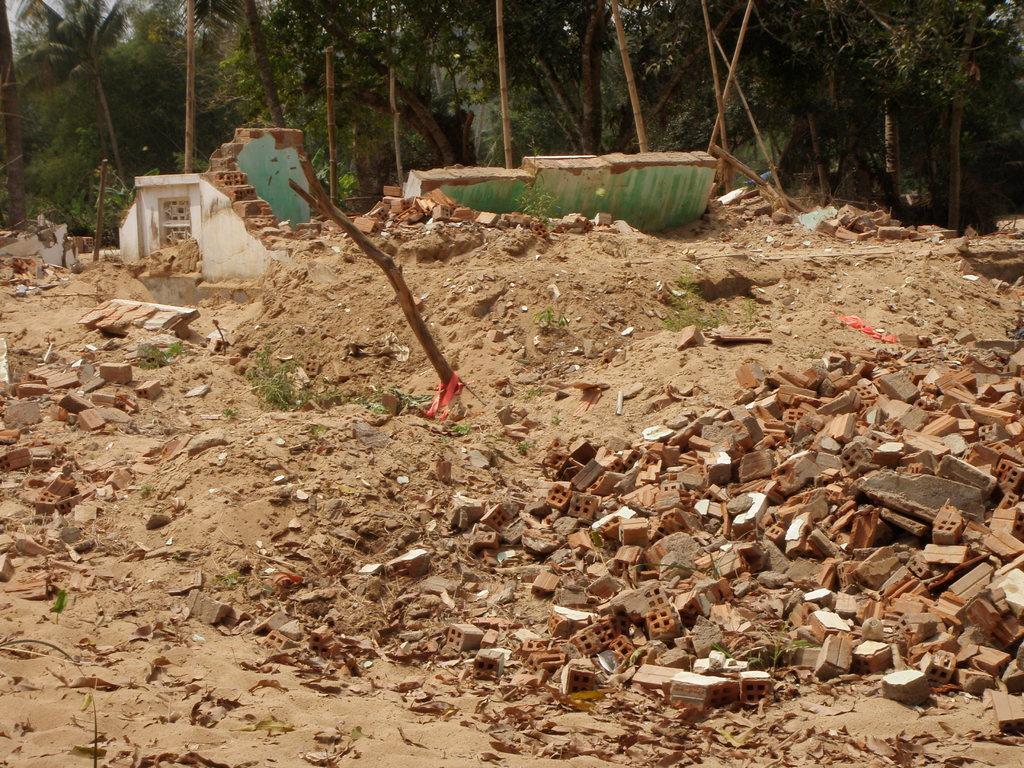How would you summarize this image in a sentence or two? In the picture I can see broken bricks on the right side of the image, we can see the broken wall and trees in the background. Here we can see the sand. 